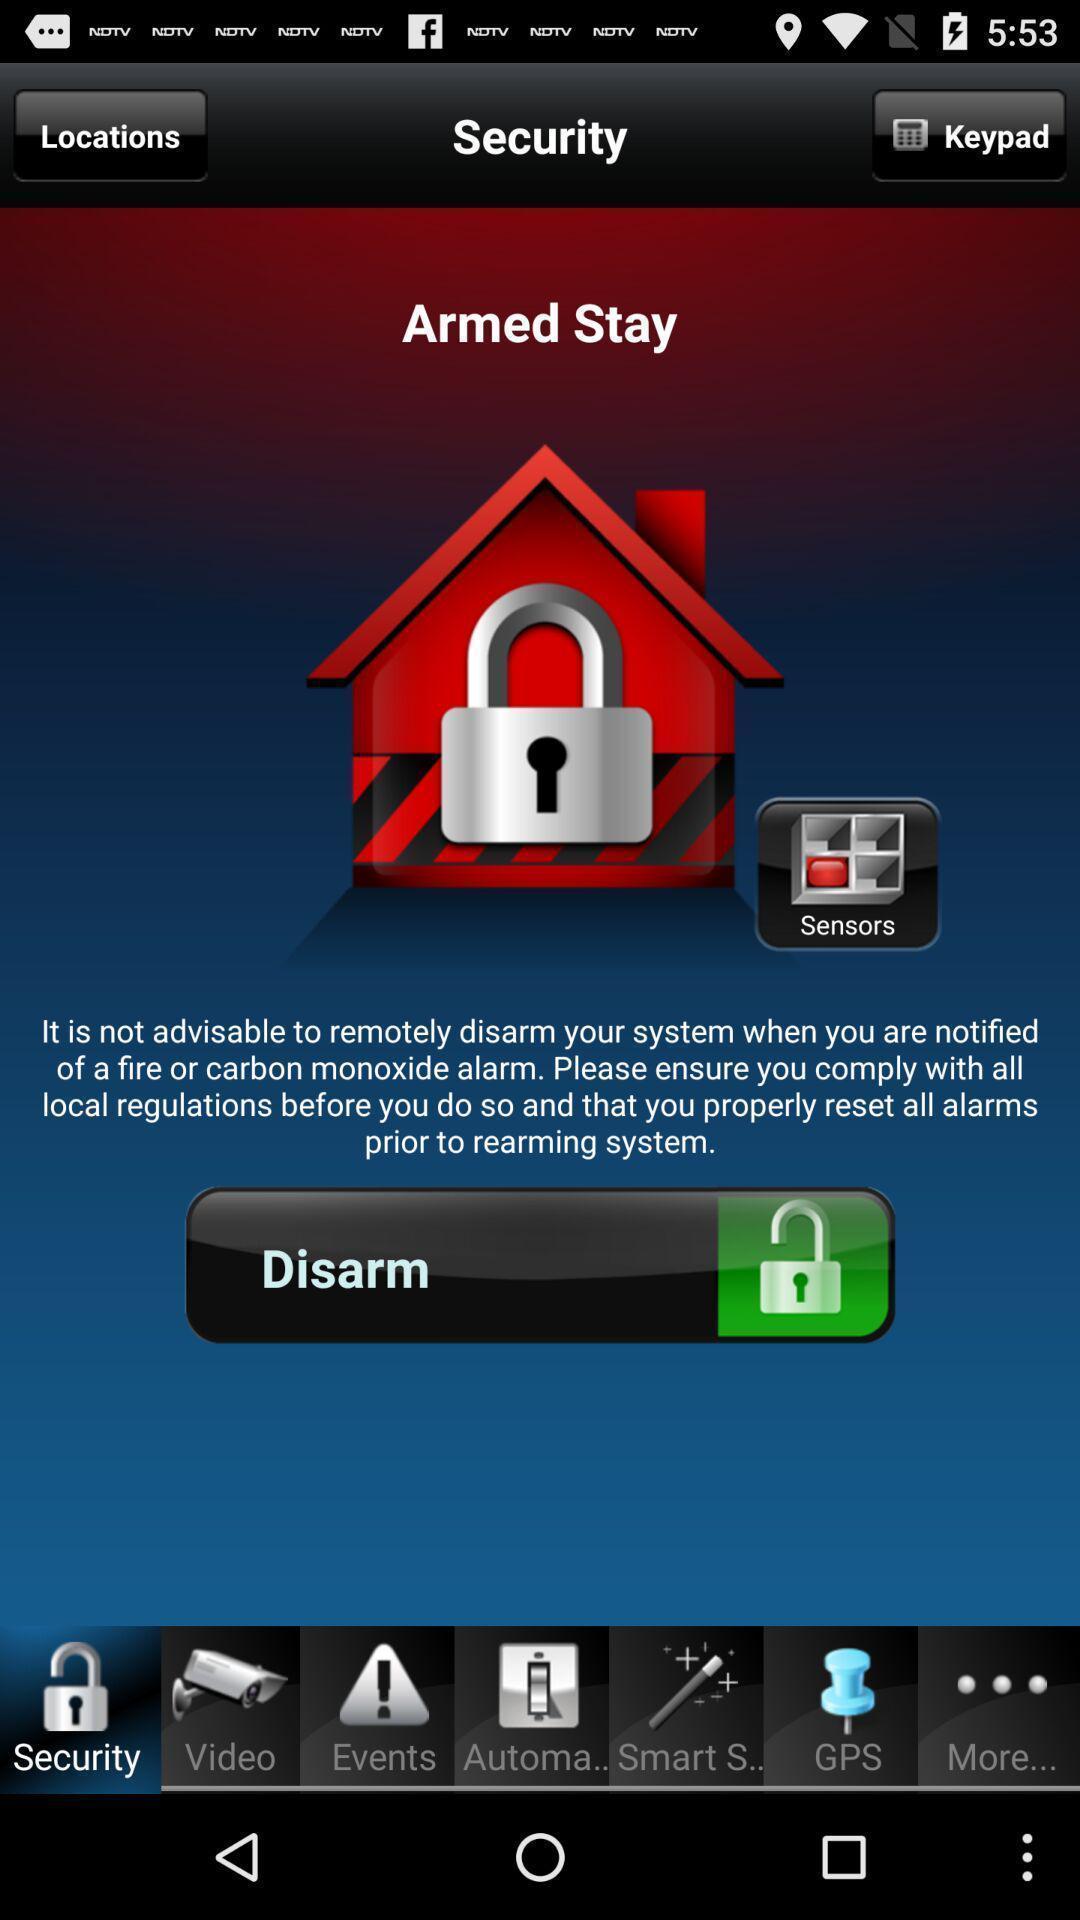What can you discern from this picture? Security page. 